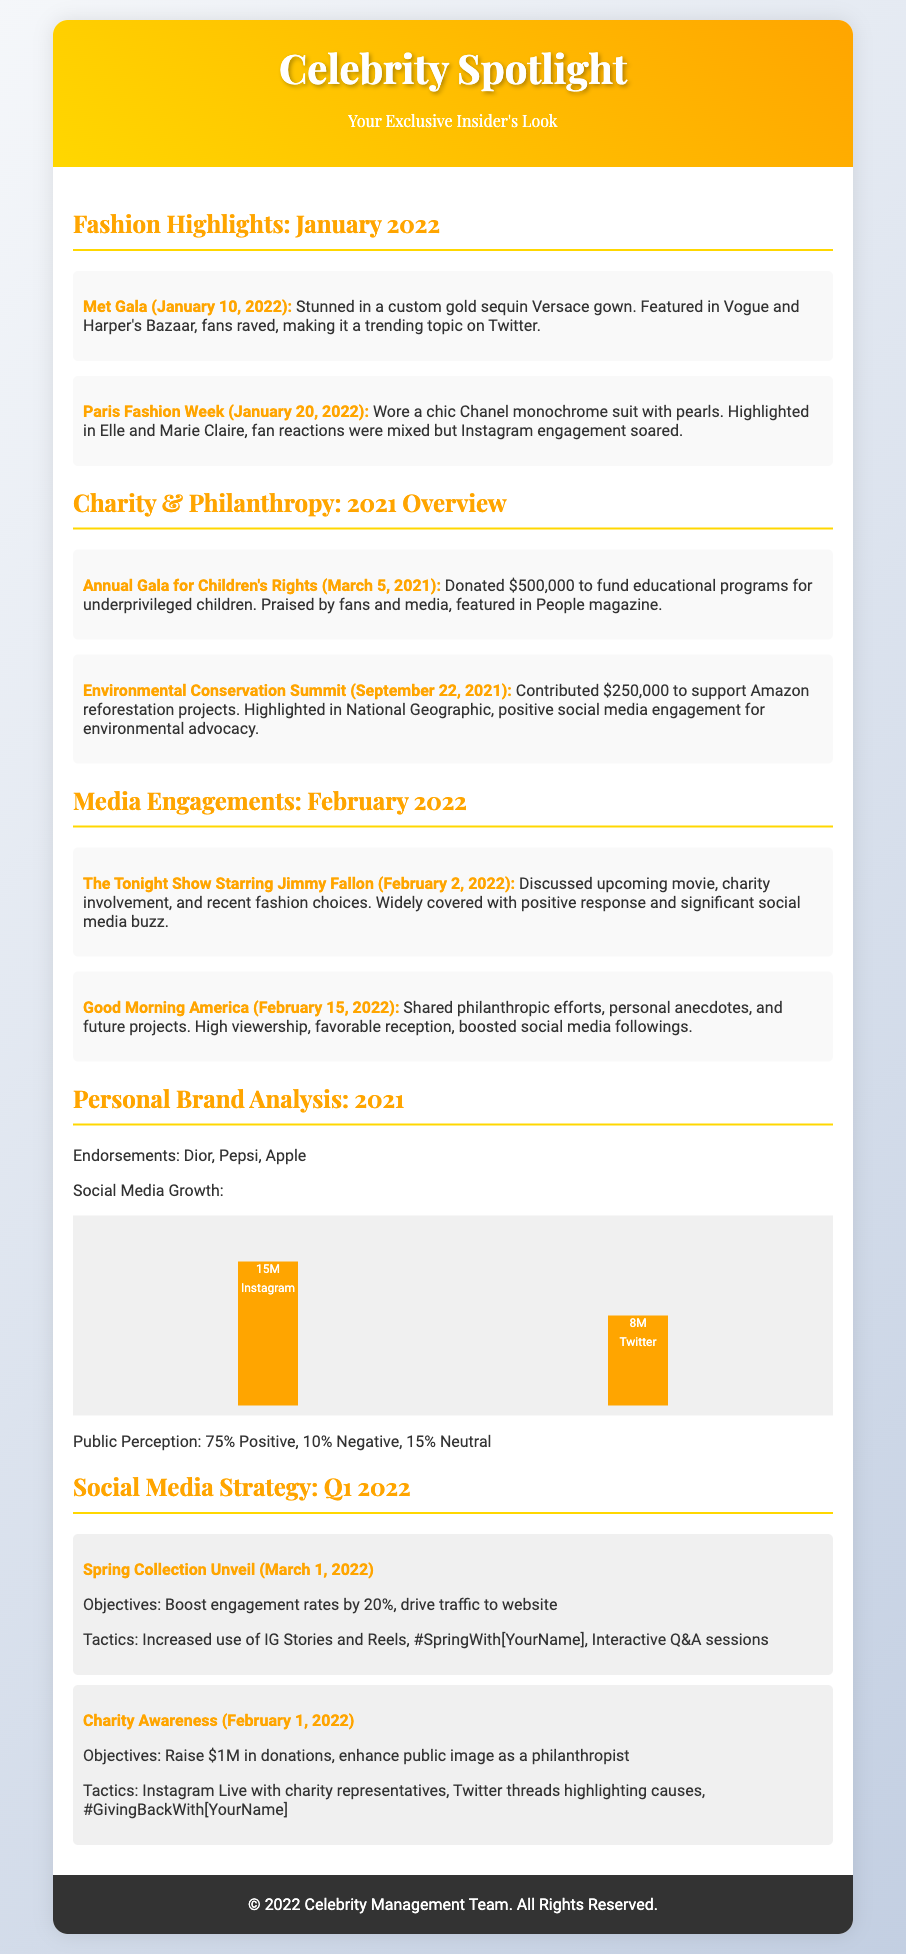What event did the celebrity attend on January 10, 2022? The event on January 10, 2022, was the Met Gala where the celebrity wore a custom gold sequin Versace gown.
Answer: Met Gala How much did the celebrity donate to the Annual Gala for Children's Rights? The celebrity donated $500,000 to fund educational programs at the Annual Gala for Children's Rights.
Answer: $500,000 What percentage of public perception was positive in 2021? The public perception was 75% positive as indicated in the document.
Answer: 75% Which brand endorsements are listed for the year 2021? The brand endorsements mentioned in the document are Dior, Pepsi, and Apple.
Answer: Dior, Pepsi, Apple What social media platform had the highest growth percentage? Instagram had the highest growth percentage with 15 million followers.
Answer: Instagram What was the objective of the Spring Collection Unveil campaign? The objective of the Spring Collection Unveil campaign was to boost engagement rates by 20%.
Answer: Boost engagement rates by 20% Which media platform did the celebrity appear on February 2, 2022? The celebrity appeared on The Tonight Show Starring Jimmy Fallon on February 2, 2022.
Answer: The Tonight Show Starring Jimmy Fallon What was the total amount donated to environmental causes? The total amount donated to environmental causes was $250,000 for the Environmental Conservation Summit.
Answer: $250,000 What was the title of the campaign planned for February 1, 2022? The campaign planned for February 1, 2022, was titled Charity Awareness.
Answer: Charity Awareness 